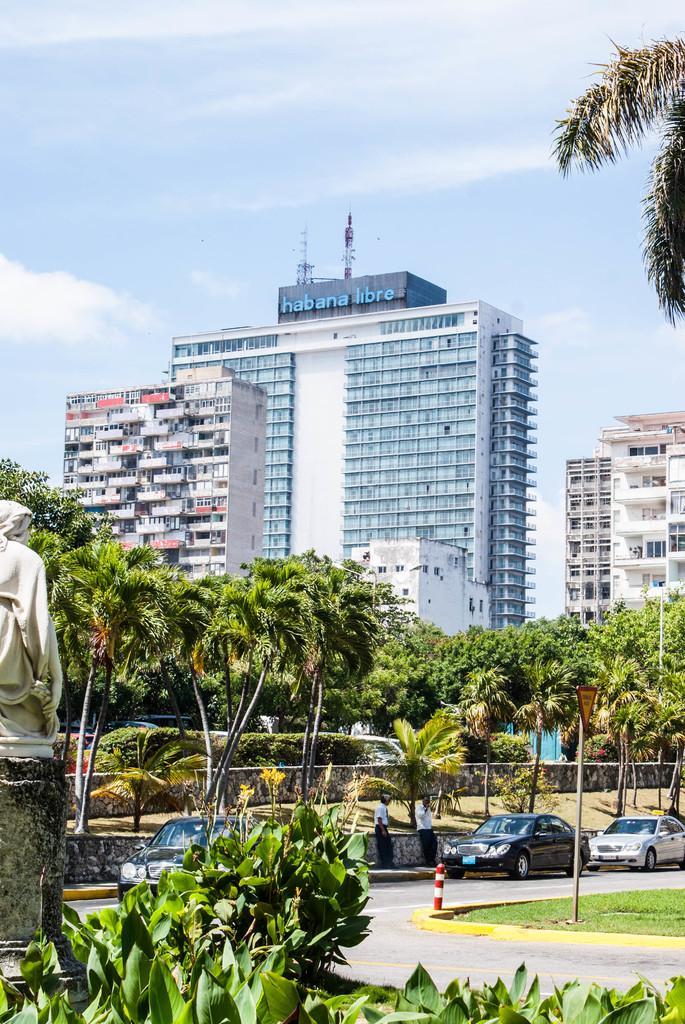How would you summarize this image in a sentence or two? In this picture we can observe a road on which there are some cars. We can observe two persons standing on the footpath. On the left side there is a white color statue. We can observe some plants and trees in the background there are buildings and a sky with some clouds. 